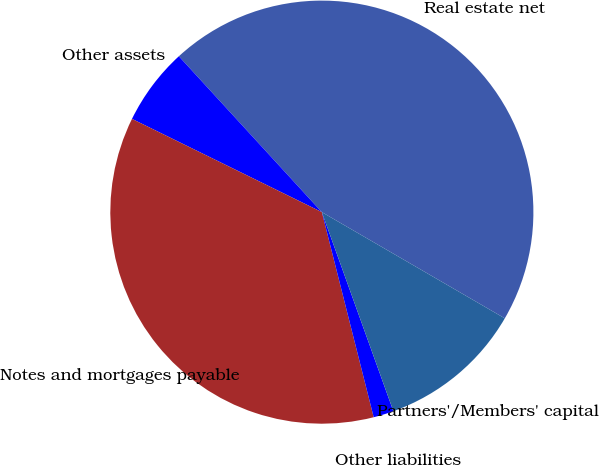Convert chart to OTSL. <chart><loc_0><loc_0><loc_500><loc_500><pie_chart><fcel>Real estate net<fcel>Other assets<fcel>Notes and mortgages payable<fcel>Other liabilities<fcel>Partners'/Members' capital<nl><fcel>45.19%<fcel>5.92%<fcel>36.21%<fcel>1.55%<fcel>11.14%<nl></chart> 